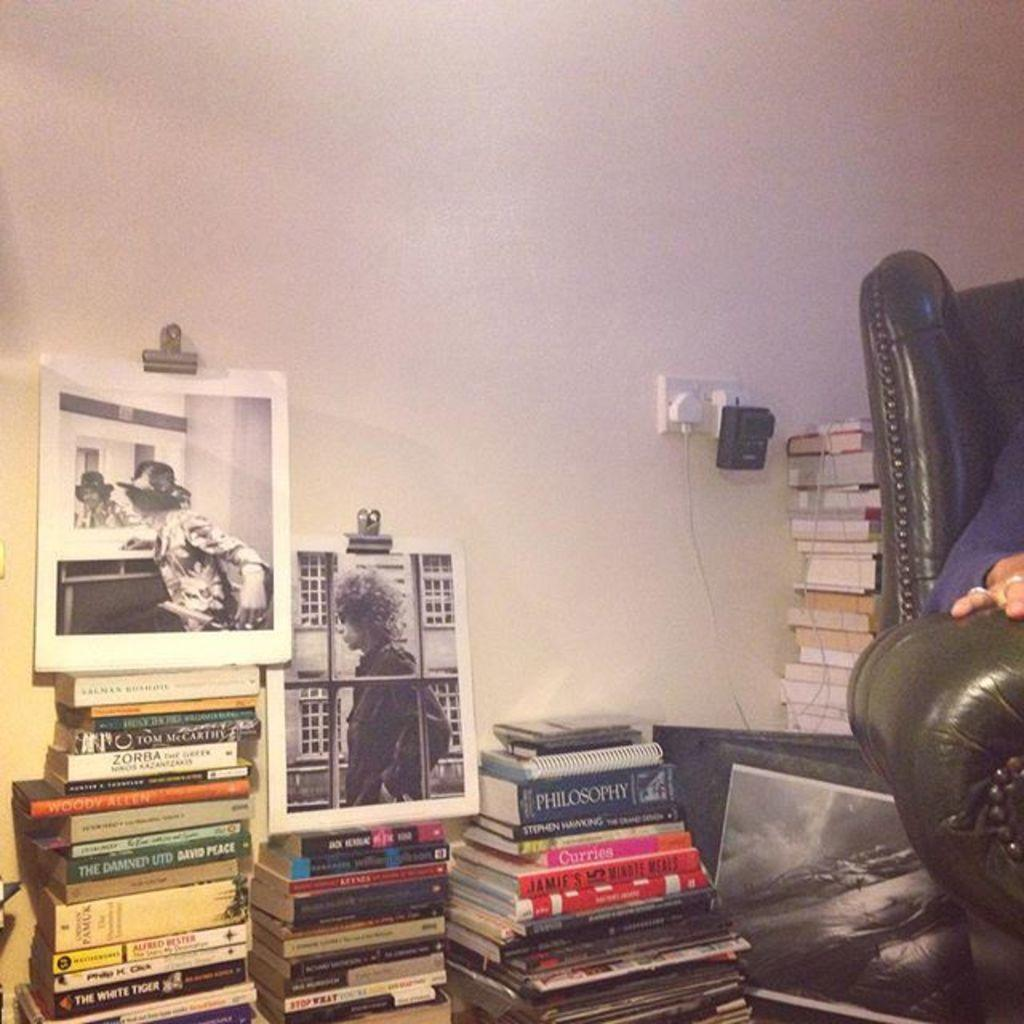What type of objects can be seen in the image? There are books in the image. What is the background of the image? There is a wall in the image. Are there any human-like figures in the image? Yes, there are depictions of persons in the image. Where is the chair located in the image? The chair is on the right side of the image. What type of team is being taught in the image? There is no team or teaching depicted in the image; it only shows books, a wall, depictions of persons, and a chair. 